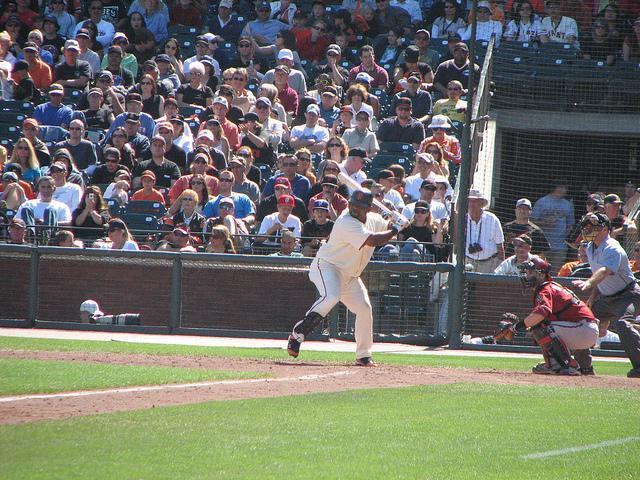What is different about this batter from most batters?
Indicate the correct response and explain using: 'Answer: answer
Rationale: rationale.'
Options: Gender, height, left-handed batter, age. Answer: left-handed batter.
Rationale: He has been in baseball for a longer time than most. 